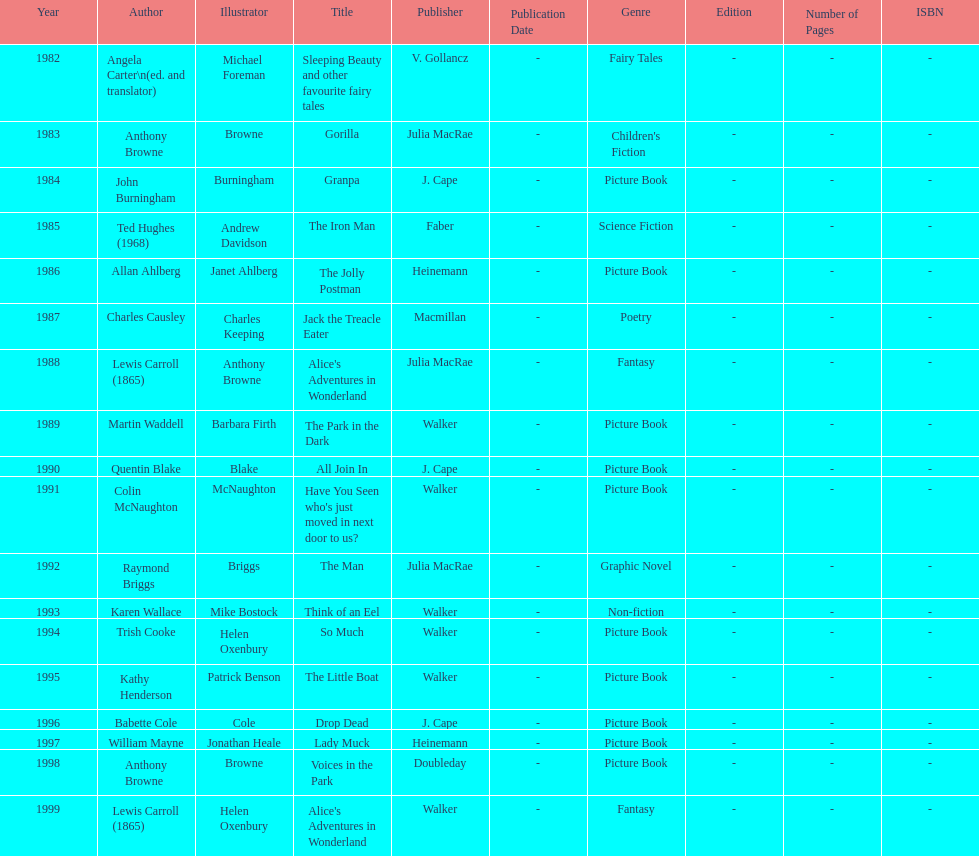Help me parse the entirety of this table. {'header': ['Year', 'Author', 'Illustrator', 'Title', 'Publisher', 'Publication Date', 'Genre', 'Edition', 'Number of Pages', 'ISBN'], 'rows': [['1982', 'Angela Carter\\n(ed. and translator)', 'Michael Foreman', 'Sleeping Beauty and other favourite fairy tales', 'V. Gollancz', '-', 'Fairy Tales', '-', '-', '-'], ['1983', 'Anthony Browne', 'Browne', 'Gorilla', 'Julia MacRae', '-', "Children's Fiction", '-', '-', '-'], ['1984', 'John Burningham', 'Burningham', 'Granpa', 'J. Cape', '-', 'Picture Book', '-', '-', '-'], ['1985', 'Ted Hughes (1968)', 'Andrew Davidson', 'The Iron Man', 'Faber', '-', 'Science Fiction', '-', '-', '-'], ['1986', 'Allan Ahlberg', 'Janet Ahlberg', 'The Jolly Postman', 'Heinemann', '-', 'Picture Book', '-', '-', '-'], ['1987', 'Charles Causley', 'Charles Keeping', 'Jack the Treacle Eater', 'Macmillan', '-', 'Poetry', '-', '-', '-'], ['1988', 'Lewis Carroll (1865)', 'Anthony Browne', "Alice's Adventures in Wonderland", 'Julia MacRae', '-', 'Fantasy', '-', '-', '-'], ['1989', 'Martin Waddell', 'Barbara Firth', 'The Park in the Dark', 'Walker', '-', 'Picture Book', '-', '-', '-'], ['1990', 'Quentin Blake', 'Blake', 'All Join In', 'J. Cape', '-', 'Picture Book', '-', '-', '-'], ['1991', 'Colin McNaughton', 'McNaughton', "Have You Seen who's just moved in next door to us?", 'Walker', '-', 'Picture Book', '-', '-', '-'], ['1992', 'Raymond Briggs', 'Briggs', 'The Man', 'Julia MacRae', '-', 'Graphic Novel', '-', '-', '-'], ['1993', 'Karen Wallace', 'Mike Bostock', 'Think of an Eel', 'Walker', '-', 'Non-fiction', '-', '-', '-'], ['1994', 'Trish Cooke', 'Helen Oxenbury', 'So Much', 'Walker', '-', 'Picture Book', '-', '-', '-'], ['1995', 'Kathy Henderson', 'Patrick Benson', 'The Little Boat', 'Walker', '-', 'Picture Book', '-', '-', '-'], ['1996', 'Babette Cole', 'Cole', 'Drop Dead', 'J. Cape', '-', 'Picture Book', '-', '-', '-'], ['1997', 'William Mayne', 'Jonathan Heale', 'Lady Muck', 'Heinemann', '-', 'Picture Book', '-', '-', '-'], ['1998', 'Anthony Browne', 'Browne', 'Voices in the Park', 'Doubleday', '-', 'Picture Book', '-', '-', '-'], ['1999', 'Lewis Carroll (1865)', 'Helen Oxenbury', "Alice's Adventures in Wonderland", 'Walker', '-', 'Fantasy', '-', '-', '-']]} What are the number of kurt maschler awards helen oxenbury has won? 2. 